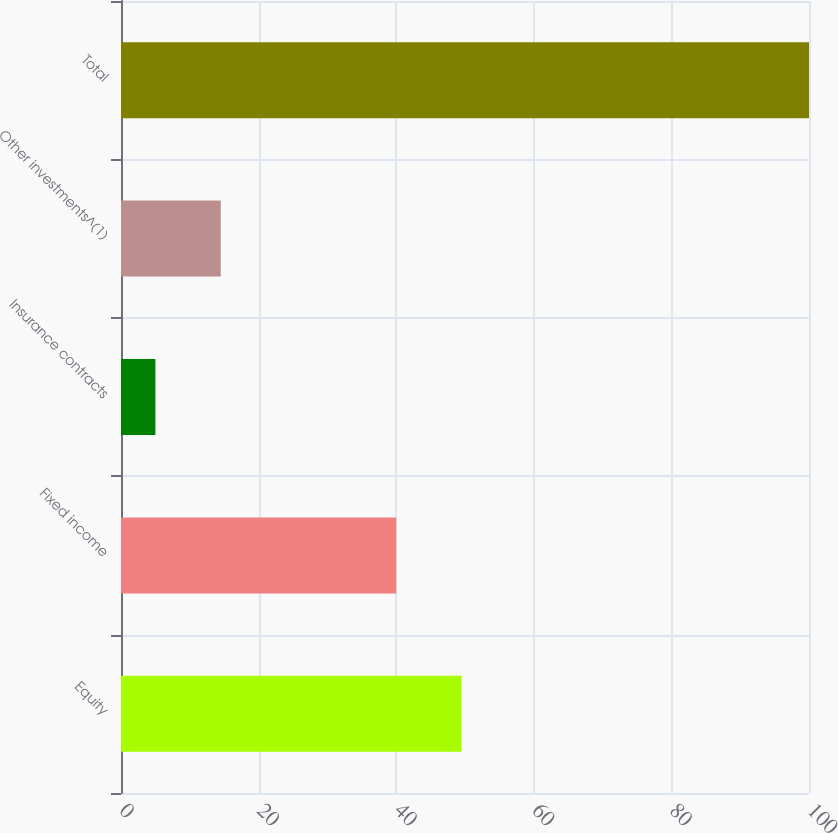<chart> <loc_0><loc_0><loc_500><loc_500><bar_chart><fcel>Equity<fcel>Fixed income<fcel>Insurance contracts<fcel>Other investments^(1)<fcel>Total<nl><fcel>49.5<fcel>40<fcel>5<fcel>14.5<fcel>100<nl></chart> 